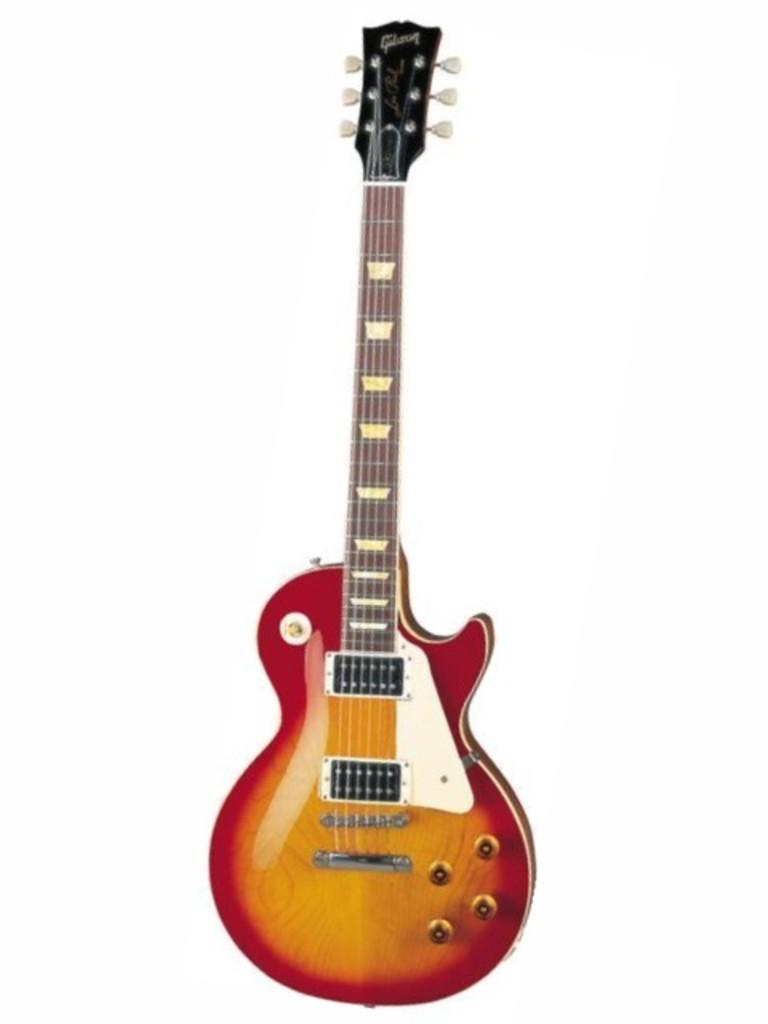What musical instrument is present in the image? There is a guitar in the image. What colors can be seen on the guitar? The guitar is red and yellow in color. What feature of the guitar is essential for playing it? The guitar has strings. How is the guitar positioned in the image? The guitar is in a standing position. What type of house is depicted in the image? There is no house present in the image; it features a guitar. What experience can be gained from playing the guitar in the image? The image does not depict anyone playing the guitar, so it is impossible to determine what experience might be gained from playing it. 